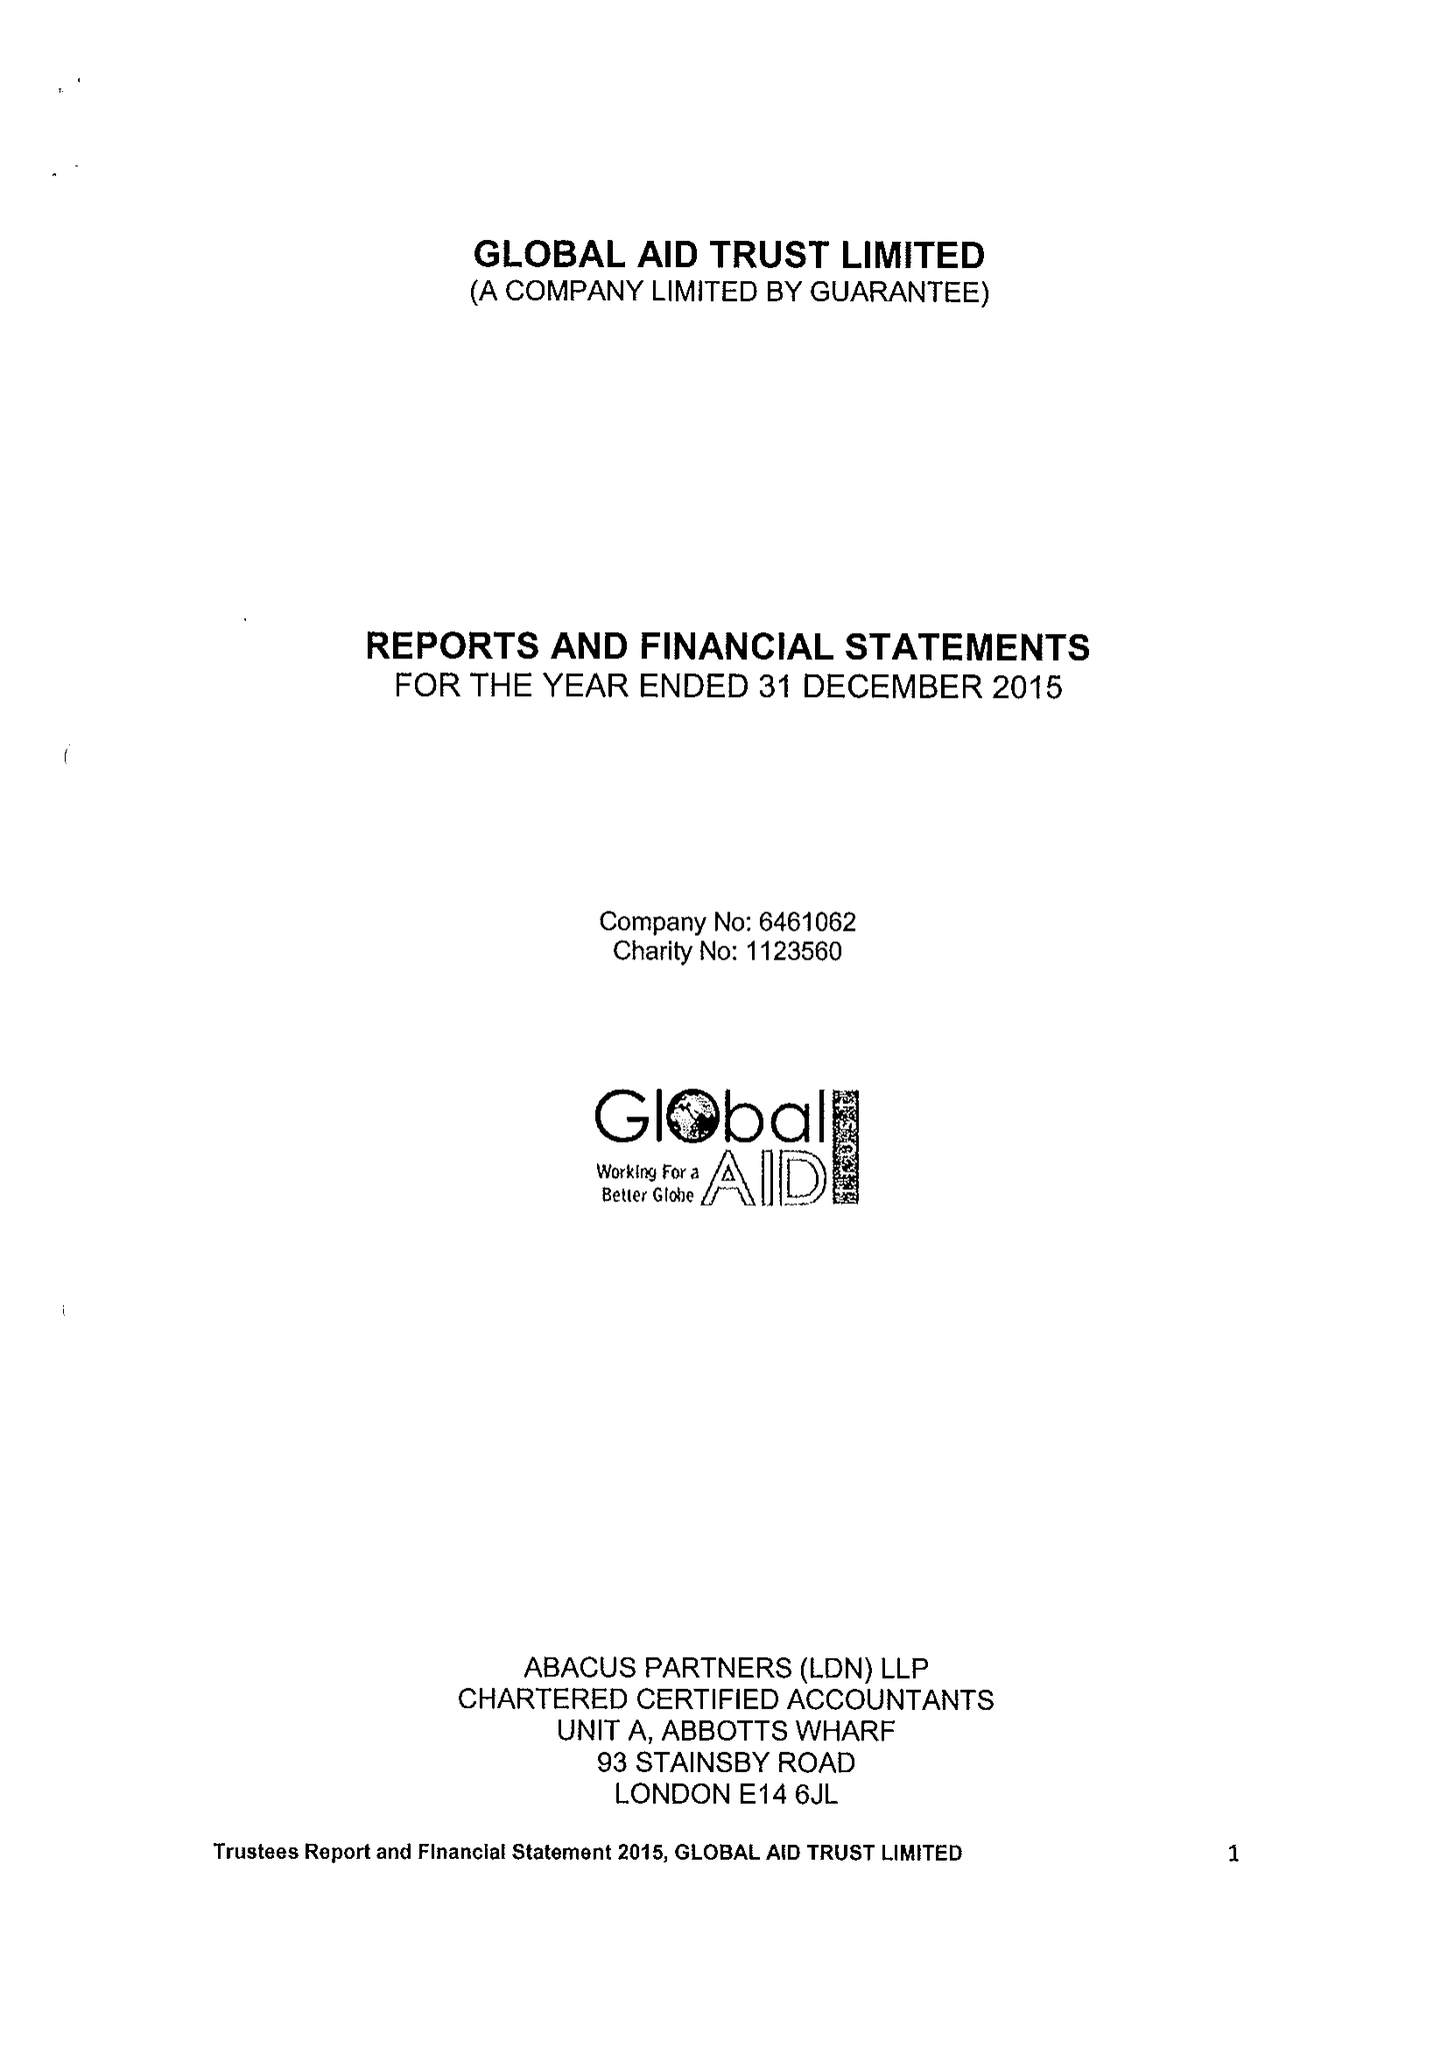What is the value for the income_annually_in_british_pounds?
Answer the question using a single word or phrase. 300672.00 